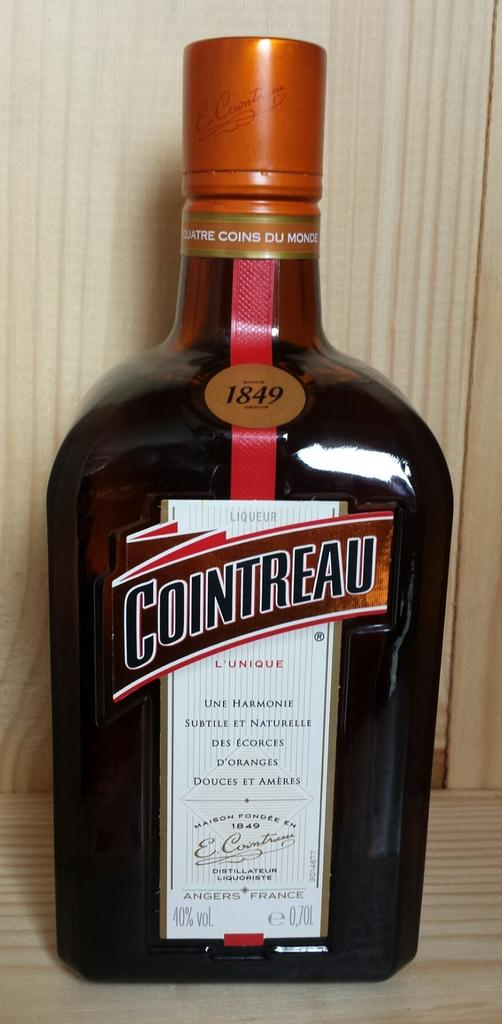<image>
Give a short and clear explanation of the subsequent image. a bottle of Cointreau liquor on the table 